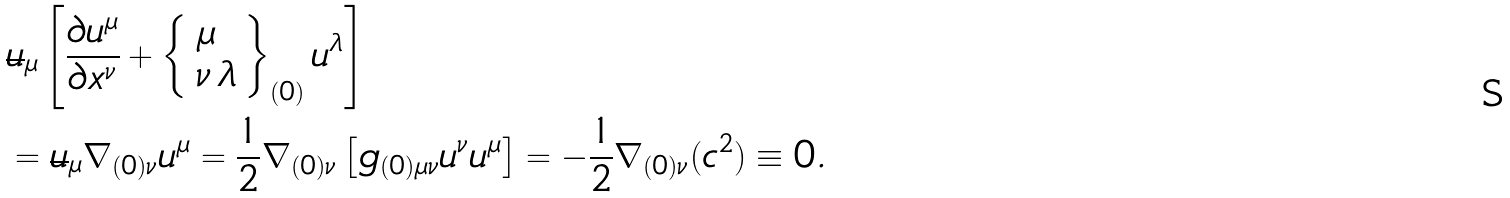<formula> <loc_0><loc_0><loc_500><loc_500>& \overline { u } _ { \mu } \left [ \frac { \partial u ^ { \mu } } { \partial x ^ { \nu } } + \left \{ \begin{array} { l } \mu \\ \nu \, \lambda \end{array} \right \} _ { ( 0 ) } u ^ { \lambda } \right ] \\ & = \overline { u } _ { \mu } \nabla _ { ( 0 ) \nu } u ^ { \mu } = \frac { 1 } { 2 } \nabla _ { ( 0 ) \nu } \left [ g _ { ( 0 ) \mu \nu } u ^ { \nu } u ^ { \mu } \right ] = - \frac { 1 } { 2 } \nabla _ { ( 0 ) \nu } ( c ^ { 2 } ) \equiv 0 .</formula> 